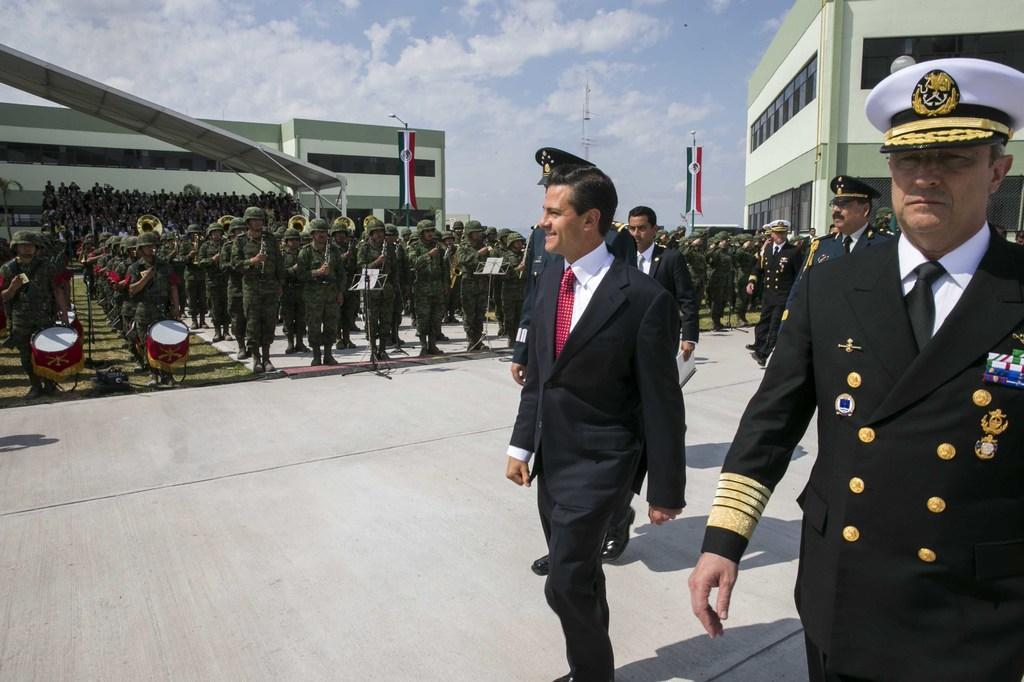Describe this image in one or two sentences. In this image there are people, buildings, flags, poles, musical drums, cloudy sky and objects. 